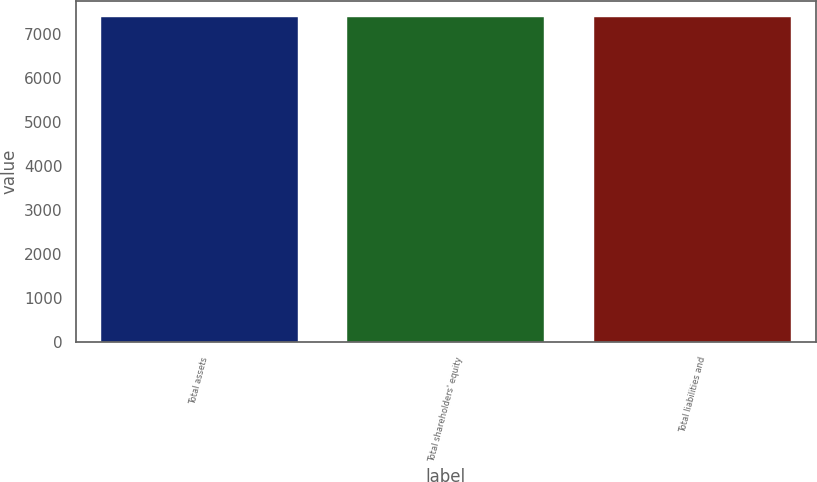<chart> <loc_0><loc_0><loc_500><loc_500><bar_chart><fcel>Total assets<fcel>Total shareholders' equity<fcel>Total liabilities and<nl><fcel>7387<fcel>7387.1<fcel>7387.2<nl></chart> 